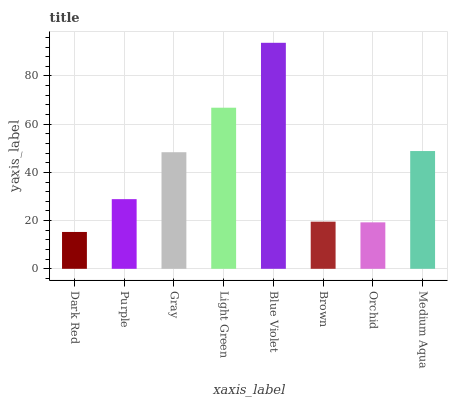Is Purple the minimum?
Answer yes or no. No. Is Purple the maximum?
Answer yes or no. No. Is Purple greater than Dark Red?
Answer yes or no. Yes. Is Dark Red less than Purple?
Answer yes or no. Yes. Is Dark Red greater than Purple?
Answer yes or no. No. Is Purple less than Dark Red?
Answer yes or no. No. Is Gray the high median?
Answer yes or no. Yes. Is Purple the low median?
Answer yes or no. Yes. Is Medium Aqua the high median?
Answer yes or no. No. Is Brown the low median?
Answer yes or no. No. 